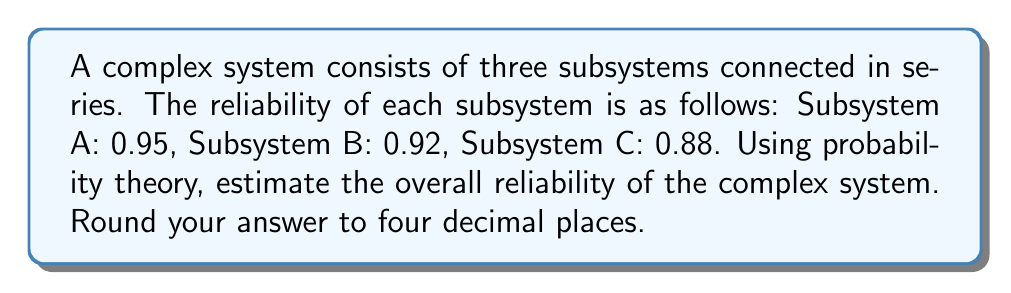Could you help me with this problem? To estimate the reliability of a complex system with subsystems connected in series, we need to use the multiplication rule of probability. This is because for the entire system to be reliable, all subsystems must be functioning.

Let's follow these steps:

1. Define the events:
   Let $R_A$, $R_B$, and $R_C$ be the events that subsystems A, B, and C are reliable, respectively.

2. Given reliabilities:
   $P(R_A) = 0.95$
   $P(R_B) = 0.92$
   $P(R_C) = 0.88$

3. For a series system, the overall reliability is the product of the individual reliabilities:
   
   $R_{system} = P(R_A \cap R_B \cap R_C) = P(R_A) \times P(R_B) \times P(R_C)$

4. Substitute the given values:
   
   $R_{system} = 0.95 \times 0.92 \times 0.88$

5. Perform the multiplication:
   
   $R_{system} = 0.7684$

6. Round to four decimal places:
   
   $R_{system} \approx 0.7684$

Therefore, the estimated reliability of the complex system is 0.7684 or about 76.84%.
Answer: 0.7684 